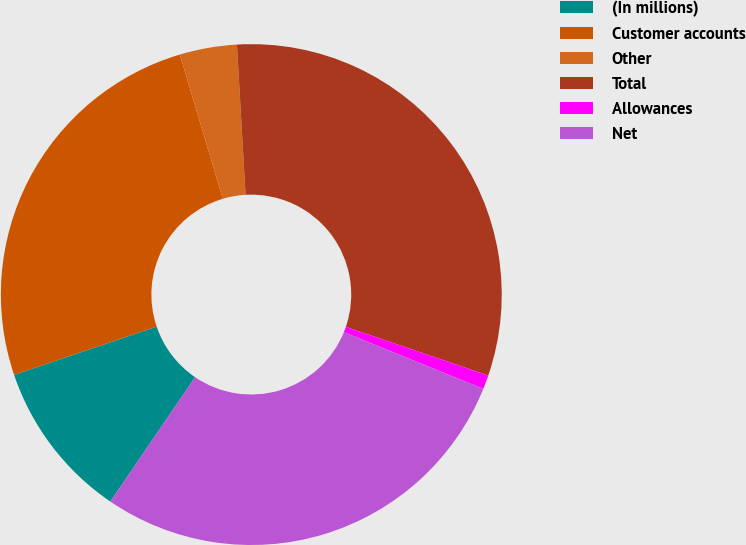Convert chart to OTSL. <chart><loc_0><loc_0><loc_500><loc_500><pie_chart><fcel>(In millions)<fcel>Customer accounts<fcel>Other<fcel>Total<fcel>Allowances<fcel>Net<nl><fcel>10.29%<fcel>25.59%<fcel>3.69%<fcel>31.15%<fcel>0.91%<fcel>28.37%<nl></chart> 